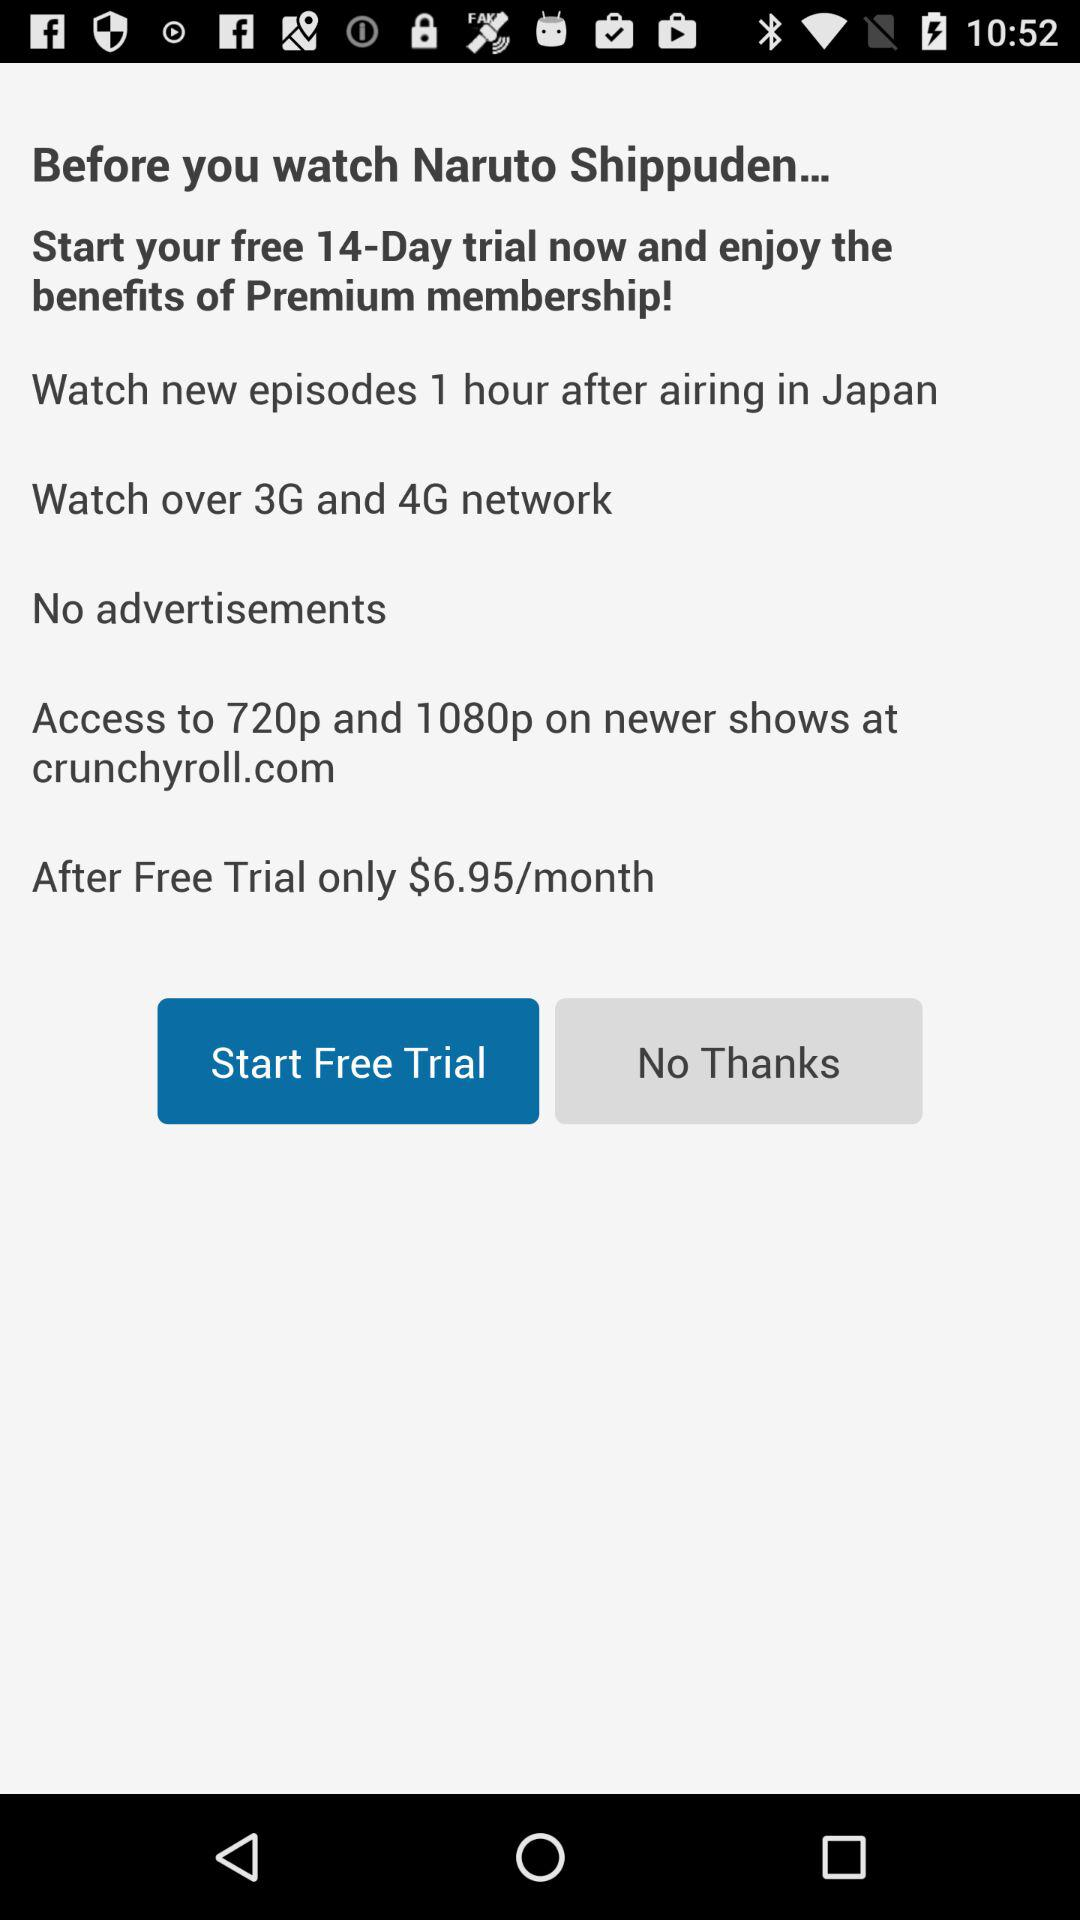What is the duration of the free trial of premium membership? The duration of the free trial of premium membership is 14 days. 